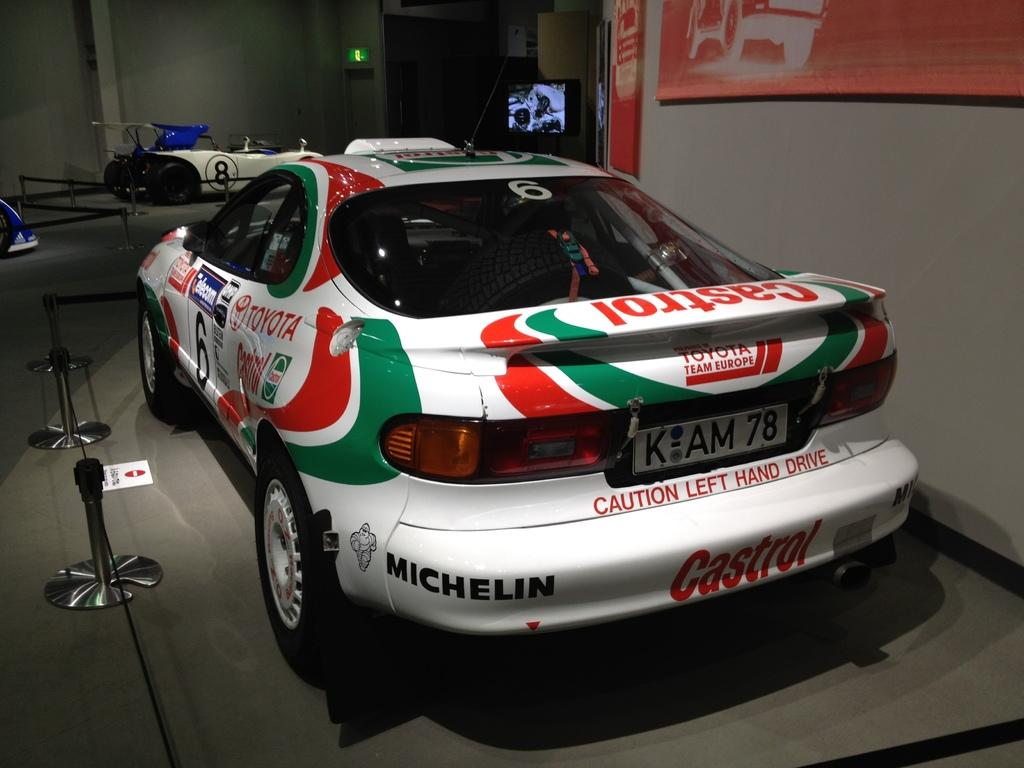What type of vehicles can be seen in the image? There are cars in the image. What is placed on the floor in the image? There is a poster on the floor. What structures are present in the image? There are stands in the image. What is used to attach or secure items in the image? There is tape in the image. What is on the wall in the image? There are boards on the wall. What can be seen in the background of the image? There is a screen visible in the background of the image. What type of ray can be seen coming out of the car in the image? There is no ray visible in the image, especially not coming out of the car. 